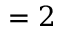<formula> <loc_0><loc_0><loc_500><loc_500>= 2</formula> 